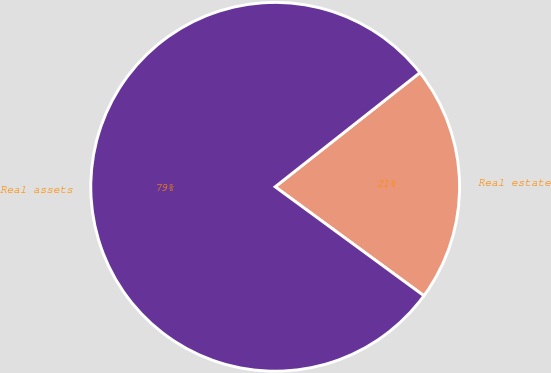<chart> <loc_0><loc_0><loc_500><loc_500><pie_chart><fcel>Real estate<fcel>Real assets<nl><fcel>20.69%<fcel>79.31%<nl></chart> 